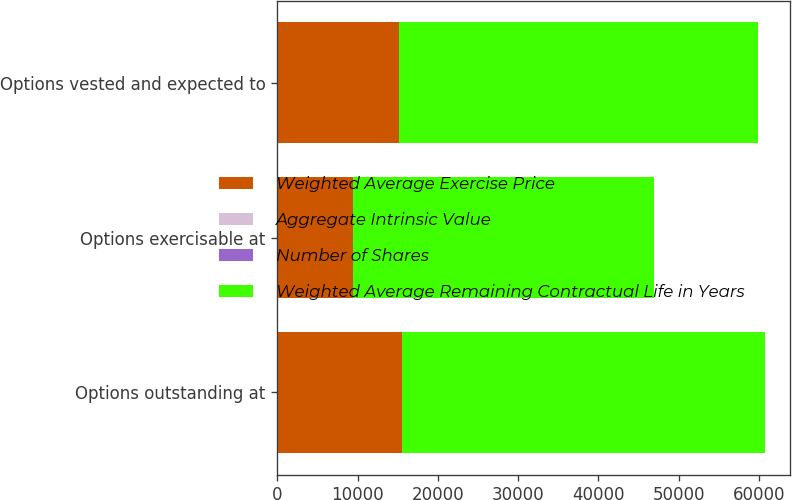Convert chart to OTSL. <chart><loc_0><loc_0><loc_500><loc_500><stacked_bar_chart><ecel><fcel>Options outstanding at<fcel>Options exercisable at<fcel>Options vested and expected to<nl><fcel>Weighted Average Exercise Price<fcel>15545<fcel>9425<fcel>15166<nl><fcel>Aggregate Intrinsic Value<fcel>16.7<fcel>15.81<fcel>16.71<nl><fcel>Number of Shares<fcel>4.45<fcel>3.68<fcel>4.41<nl><fcel>Weighted Average Remaining Contractual Life in Years<fcel>45218<fcel>37452<fcel>44720<nl></chart> 